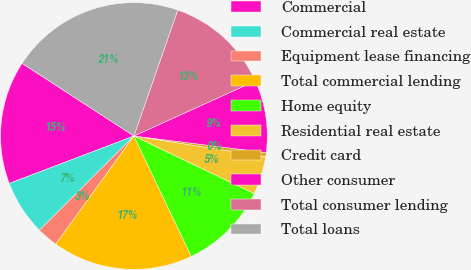Convert chart to OTSL. <chart><loc_0><loc_0><loc_500><loc_500><pie_chart><fcel>Commercial<fcel>Commercial real estate<fcel>Equipment lease financing<fcel>Total commercial lending<fcel>Home equity<fcel>Residential real estate<fcel>Credit card<fcel>Other consumer<fcel>Total consumer lending<fcel>Total loans<nl><fcel>14.96%<fcel>6.69%<fcel>2.56%<fcel>17.03%<fcel>10.83%<fcel>4.62%<fcel>0.49%<fcel>8.76%<fcel>12.89%<fcel>21.16%<nl></chart> 